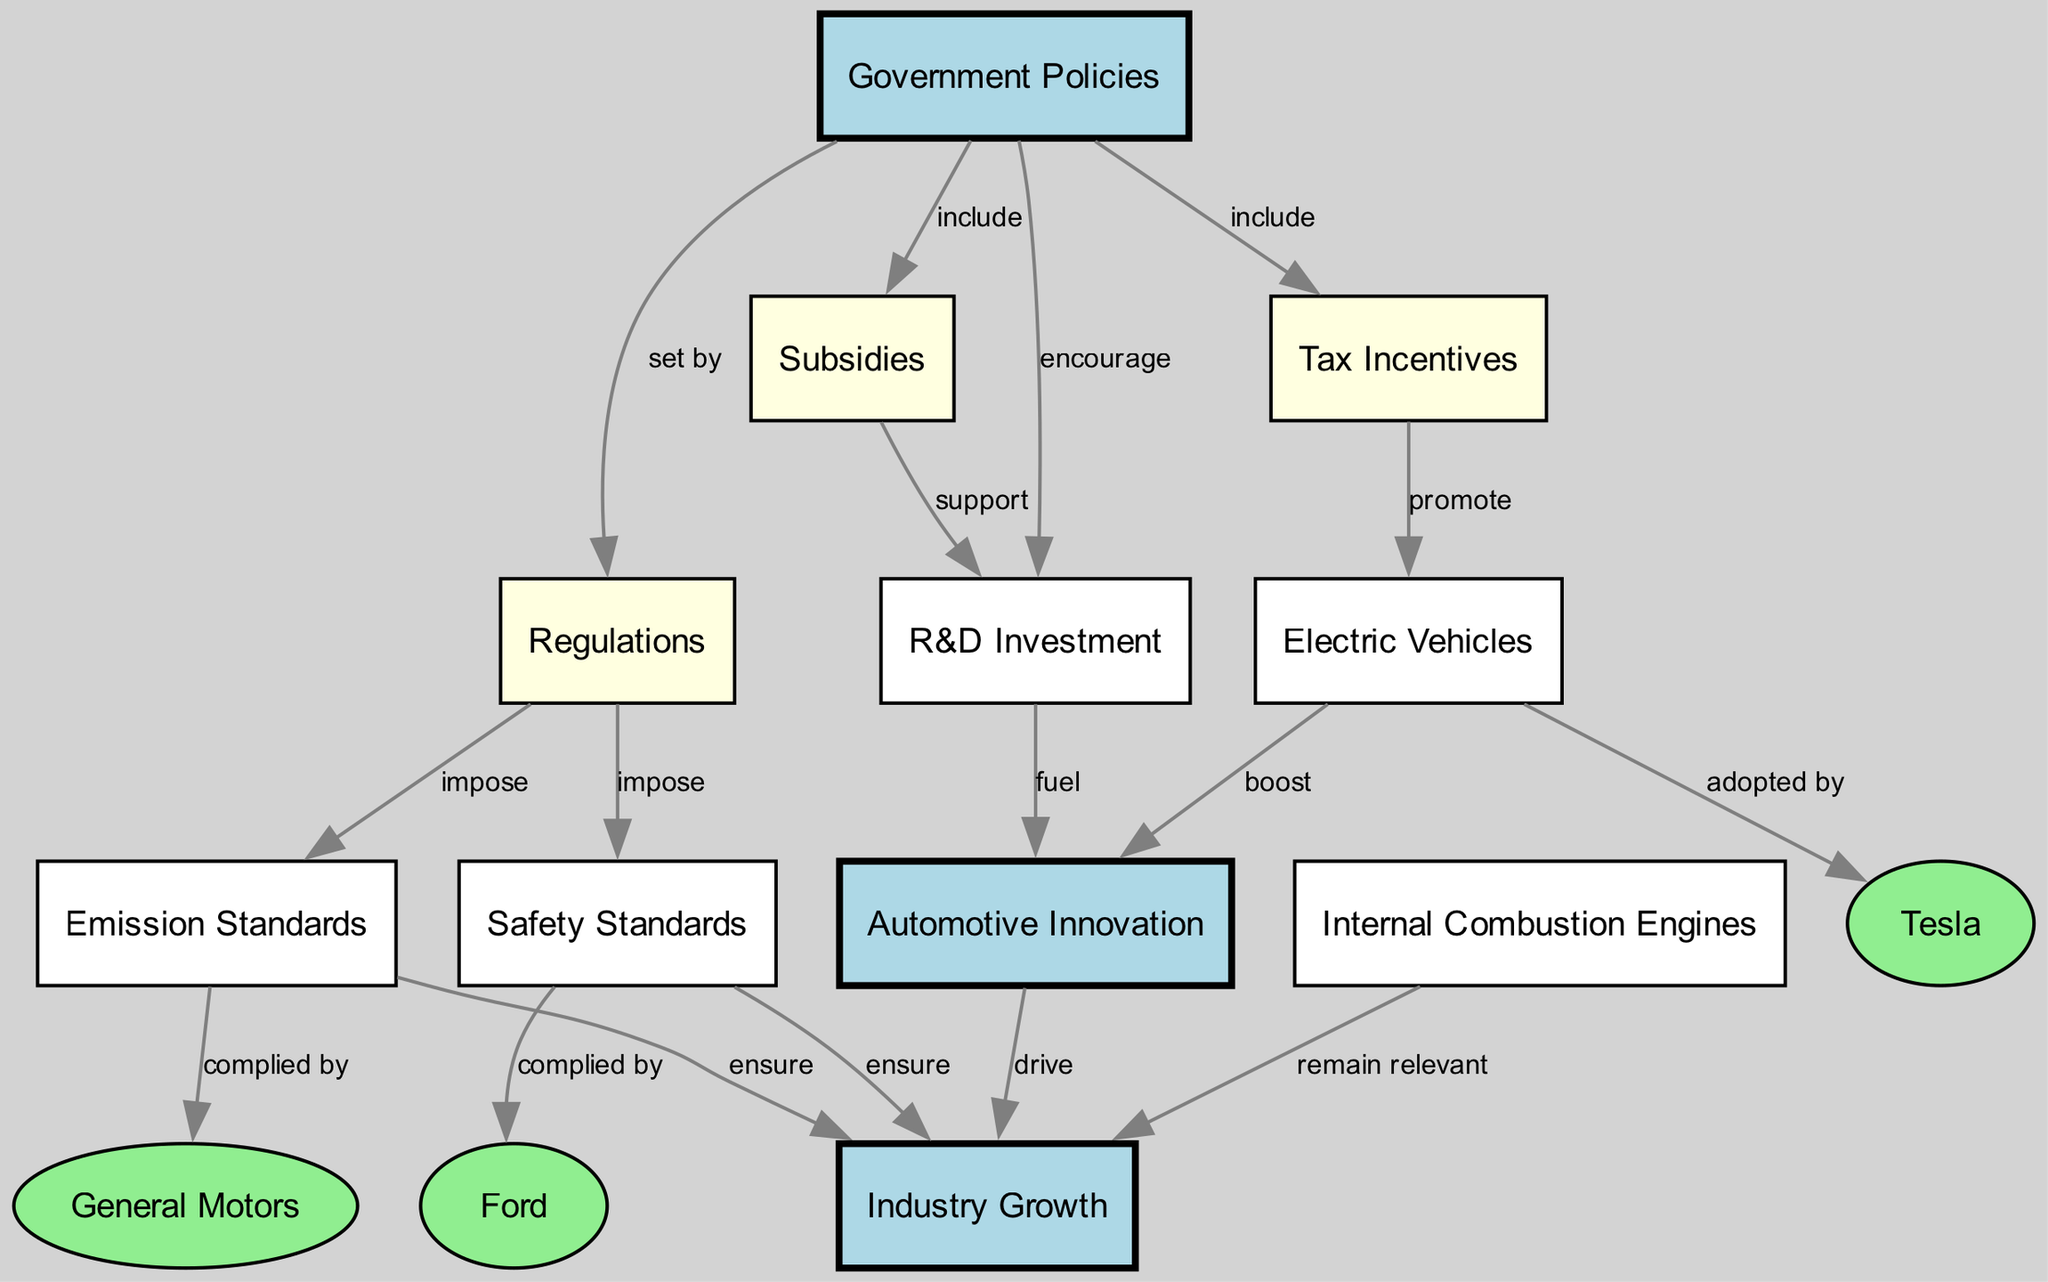What nodes are connected to government policies? The node for government policies is connected to regulations, tax incentives, subsidies, and R&D investment. These connections represent the various aspects of government policies affecting the automotive industry.
Answer: regulations, tax incentives, subsidies, R&D investment How many nodes are present in the diagram? By counting the unique nodes listed in the diagram, we find there are 14 nodes in total. This includes all types of nodes, such as government policies, regulations, companies, and various automotive innovations.
Answer: 14 Which companies comply with safety standards? The diagram indicates that Ford is the company that complies with safety standards, as per the edge connecting these two nodes.
Answer: Ford What role do tax incentives play in the promotion of electric vehicles? Tax incentives promote electric vehicles as indicated by the direct connection between the tax incentives node and the electric vehicles node in the diagram.
Answer: promote How do regulations influence industry growth? Regulations impose safety standards and emission standards, both of which ensure industry growth, as shown through the edges leading from regulations to these standards, which then connect to industry growth.
Answer: ensure What is the main influence of R&D investment on automotive innovation? R&D investment fuels innovation, which indicates that without adequate investment in research and development, the potential for innovation may be significantly hindered.
Answer: fuel Which automotive company is adopted by electric vehicles? The node for electric vehicles shows a direct connection to Tesla, indicating that Tesla is the company most prominently associated with electric vehicles.
Answer: Tesla What is the relationship between emission standards and industry growth? Emission standards ensure industry growth as evidenced by the direct connection from emission standards to industry growth in the diagram.
Answer: ensure How do subsidies contribute to R&D investment? Subsidies support R&D investment, indicating a financial backing and encouragement for companies to allocate funds towards research and development efforts.
Answer: support 